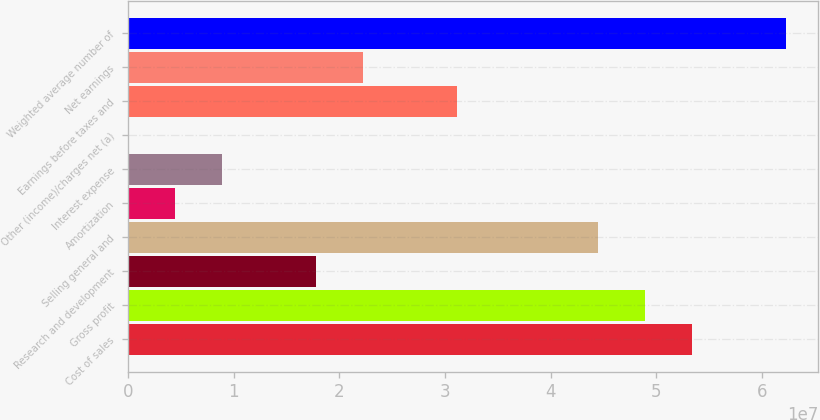Convert chart. <chart><loc_0><loc_0><loc_500><loc_500><bar_chart><fcel>Cost of sales<fcel>Gross profit<fcel>Research and development<fcel>Selling general and<fcel>Amortization<fcel>Interest expense<fcel>Other (income)/charges net (a)<fcel>Earnings before taxes and<fcel>Net earnings<fcel>Weighted average number of<nl><fcel>5.33678e+07<fcel>4.89208e+07<fcel>1.77923e+07<fcel>4.44739e+07<fcel>4.4515e+06<fcel>8.89843e+06<fcel>4563<fcel>3.11331e+07<fcel>2.22392e+07<fcel>6.22617e+07<nl></chart> 